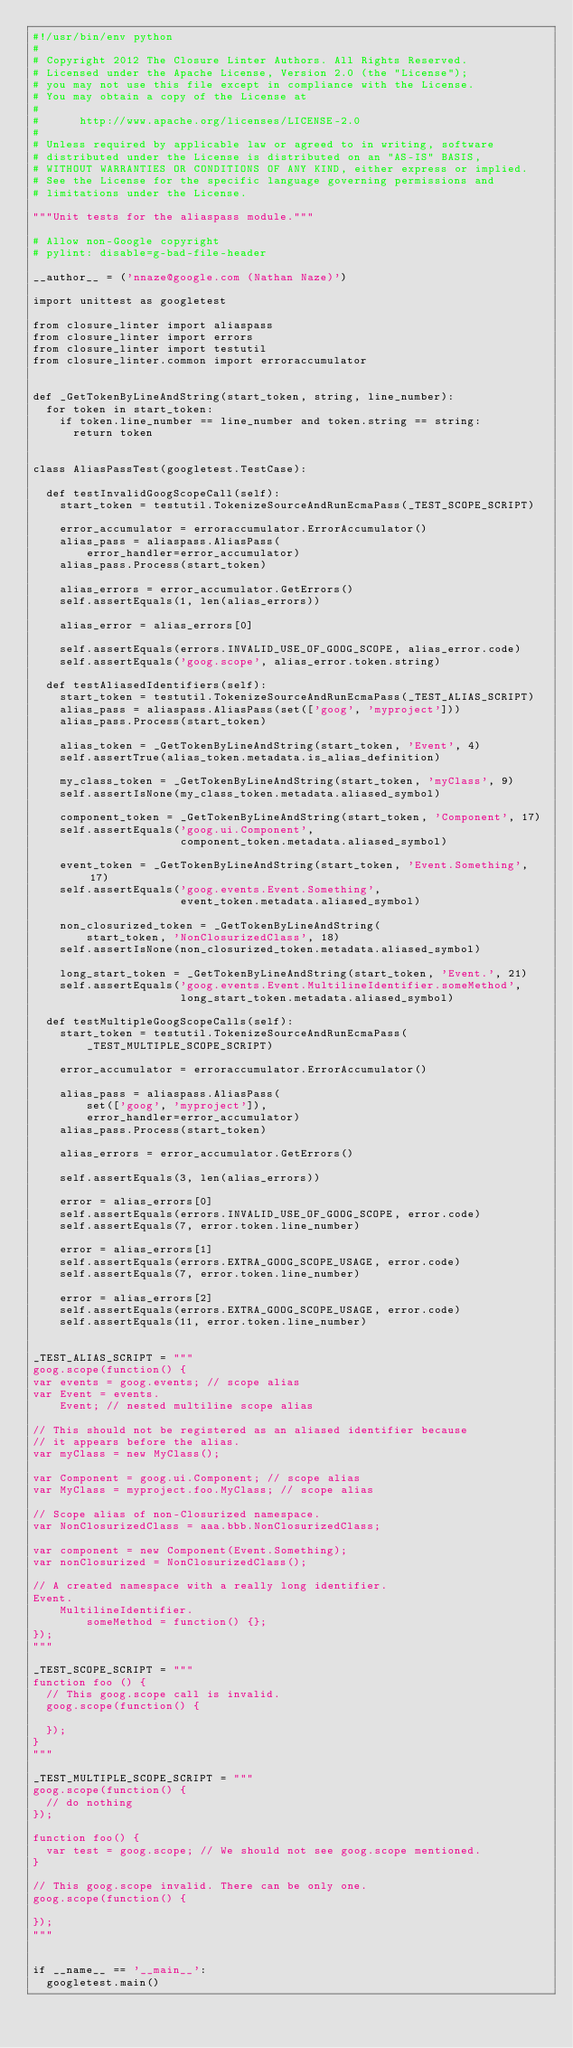<code> <loc_0><loc_0><loc_500><loc_500><_Python_>#!/usr/bin/env python
#
# Copyright 2012 The Closure Linter Authors. All Rights Reserved.
# Licensed under the Apache License, Version 2.0 (the "License");
# you may not use this file except in compliance with the License.
# You may obtain a copy of the License at
#
#      http://www.apache.org/licenses/LICENSE-2.0
#
# Unless required by applicable law or agreed to in writing, software
# distributed under the License is distributed on an "AS-IS" BASIS,
# WITHOUT WARRANTIES OR CONDITIONS OF ANY KIND, either express or implied.
# See the License for the specific language governing permissions and
# limitations under the License.

"""Unit tests for the aliaspass module."""

# Allow non-Google copyright
# pylint: disable=g-bad-file-header

__author__ = ('nnaze@google.com (Nathan Naze)')

import unittest as googletest

from closure_linter import aliaspass
from closure_linter import errors
from closure_linter import testutil
from closure_linter.common import erroraccumulator


def _GetTokenByLineAndString(start_token, string, line_number):
  for token in start_token:
    if token.line_number == line_number and token.string == string:
      return token


class AliasPassTest(googletest.TestCase):

  def testInvalidGoogScopeCall(self):
    start_token = testutil.TokenizeSourceAndRunEcmaPass(_TEST_SCOPE_SCRIPT)

    error_accumulator = erroraccumulator.ErrorAccumulator()
    alias_pass = aliaspass.AliasPass(
        error_handler=error_accumulator)
    alias_pass.Process(start_token)

    alias_errors = error_accumulator.GetErrors()
    self.assertEquals(1, len(alias_errors))

    alias_error = alias_errors[0]

    self.assertEquals(errors.INVALID_USE_OF_GOOG_SCOPE, alias_error.code)
    self.assertEquals('goog.scope', alias_error.token.string)

  def testAliasedIdentifiers(self):
    start_token = testutil.TokenizeSourceAndRunEcmaPass(_TEST_ALIAS_SCRIPT)
    alias_pass = aliaspass.AliasPass(set(['goog', 'myproject']))
    alias_pass.Process(start_token)

    alias_token = _GetTokenByLineAndString(start_token, 'Event', 4)
    self.assertTrue(alias_token.metadata.is_alias_definition)

    my_class_token = _GetTokenByLineAndString(start_token, 'myClass', 9)
    self.assertIsNone(my_class_token.metadata.aliased_symbol)

    component_token = _GetTokenByLineAndString(start_token, 'Component', 17)
    self.assertEquals('goog.ui.Component',
                      component_token.metadata.aliased_symbol)

    event_token = _GetTokenByLineAndString(start_token, 'Event.Something', 17)
    self.assertEquals('goog.events.Event.Something',
                      event_token.metadata.aliased_symbol)

    non_closurized_token = _GetTokenByLineAndString(
        start_token, 'NonClosurizedClass', 18)
    self.assertIsNone(non_closurized_token.metadata.aliased_symbol)

    long_start_token = _GetTokenByLineAndString(start_token, 'Event.', 21)
    self.assertEquals('goog.events.Event.MultilineIdentifier.someMethod',
                      long_start_token.metadata.aliased_symbol)

  def testMultipleGoogScopeCalls(self):
    start_token = testutil.TokenizeSourceAndRunEcmaPass(
        _TEST_MULTIPLE_SCOPE_SCRIPT)

    error_accumulator = erroraccumulator.ErrorAccumulator()

    alias_pass = aliaspass.AliasPass(
        set(['goog', 'myproject']),
        error_handler=error_accumulator)
    alias_pass.Process(start_token)

    alias_errors = error_accumulator.GetErrors()

    self.assertEquals(3, len(alias_errors))

    error = alias_errors[0]
    self.assertEquals(errors.INVALID_USE_OF_GOOG_SCOPE, error.code)
    self.assertEquals(7, error.token.line_number)

    error = alias_errors[1]
    self.assertEquals(errors.EXTRA_GOOG_SCOPE_USAGE, error.code)
    self.assertEquals(7, error.token.line_number)

    error = alias_errors[2]
    self.assertEquals(errors.EXTRA_GOOG_SCOPE_USAGE, error.code)
    self.assertEquals(11, error.token.line_number)


_TEST_ALIAS_SCRIPT = """
goog.scope(function() {
var events = goog.events; // scope alias
var Event = events.
    Event; // nested multiline scope alias

// This should not be registered as an aliased identifier because
// it appears before the alias.
var myClass = new MyClass();

var Component = goog.ui.Component; // scope alias
var MyClass = myproject.foo.MyClass; // scope alias

// Scope alias of non-Closurized namespace.
var NonClosurizedClass = aaa.bbb.NonClosurizedClass;

var component = new Component(Event.Something);
var nonClosurized = NonClosurizedClass();

// A created namespace with a really long identifier.
Event.
    MultilineIdentifier.
        someMethod = function() {};
});
"""

_TEST_SCOPE_SCRIPT = """
function foo () {
  // This goog.scope call is invalid.
  goog.scope(function() {

  });
}
"""

_TEST_MULTIPLE_SCOPE_SCRIPT = """
goog.scope(function() {
  // do nothing
});

function foo() {
  var test = goog.scope; // We should not see goog.scope mentioned.
}

// This goog.scope invalid. There can be only one.
goog.scope(function() {

});
"""


if __name__ == '__main__':
  googletest.main()
</code> 